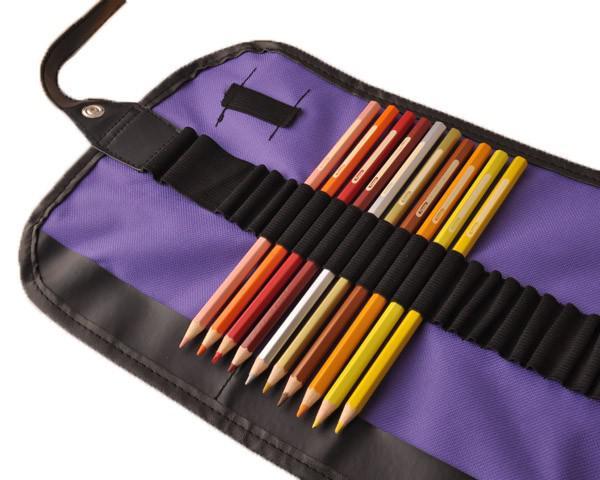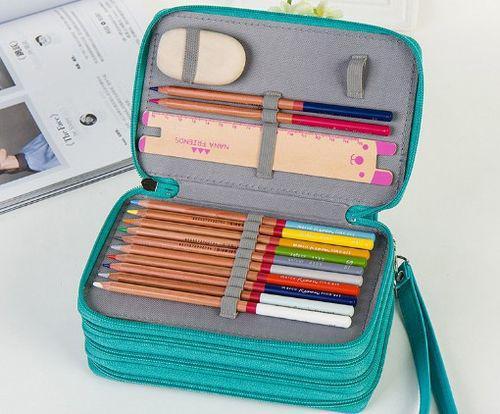The first image is the image on the left, the second image is the image on the right. Given the left and right images, does the statement "Some of the pencils are in a case made of metal." hold true? Answer yes or no. No. The first image is the image on the left, the second image is the image on the right. Evaluate the accuracy of this statement regarding the images: "The pencils in the image on the left are laying with their points facing down and slightly left.". Is it true? Answer yes or no. Yes. 